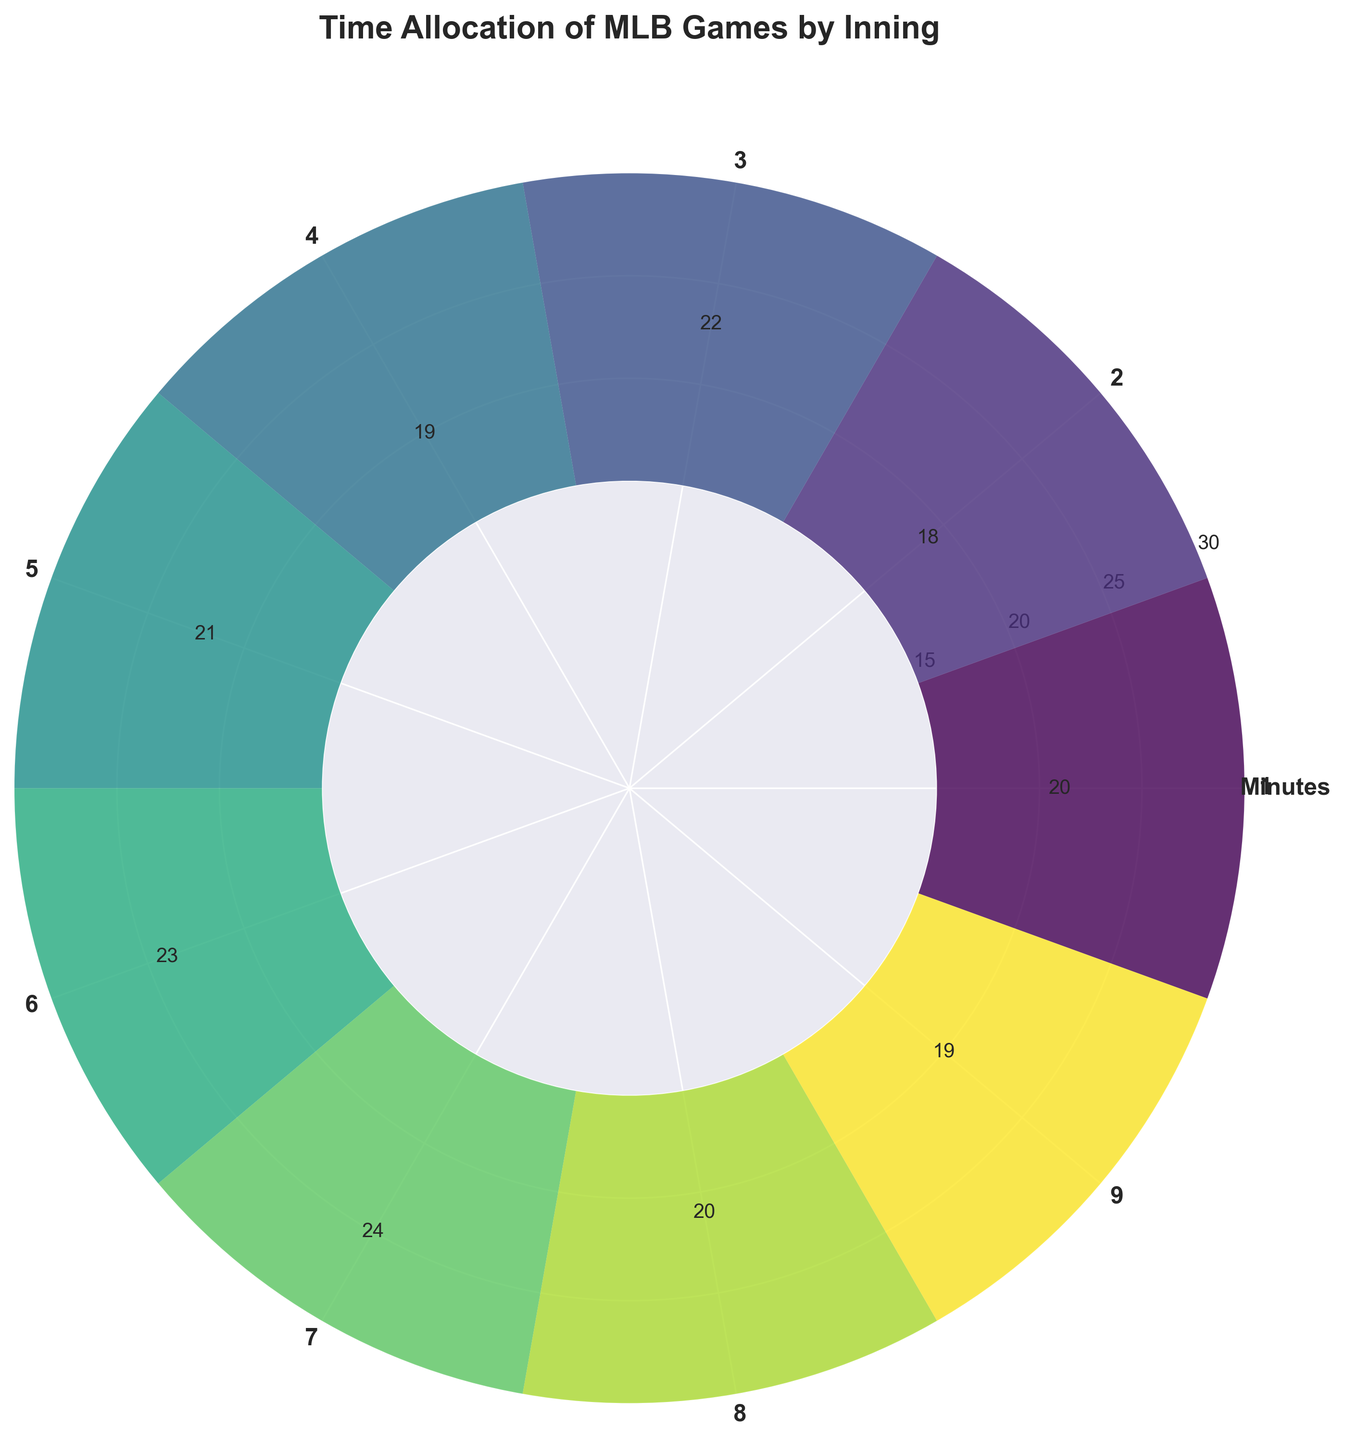Which inning has the highest time allocation? By examining the plot, the seventh inning has the highest bar, indicating it has the highest time allocation.
Answer: 7th inning What's the difference in time allocation between the third and fourth innings? The third inning has a time allocation of 22 minutes, and the fourth inning has 19 minutes. The difference is 22 - 19 = 3 minutes.
Answer: 3 minutes How many innings have a time allocation of 20 minutes or more? Checking the figure, the bars for the 1st, 3rd, 5th, 6th, 7th, and 8th innings reach or exceed 20 minutes. There are 6 such innings.
Answer: 6 innings What is the average time allocation per inning? Adding up the time allocations (20 + 18 + 22 + 19 + 21 + 23 + 24 + 20 + 19) gives 186 minutes. Dividing by the number of innings (9) results in an average of 186 / 9 = 20.67 minutes.
Answer: 20.67 minutes Which innings have the same time allocation? Looking at the plot, the 1st and 8th innings both show bars reaching 20 minutes, and the 4th and 9th innings both show bars reaching 19 minutes.
Answer: 1st and 8th, 4th and 9th What is the total time allocation for the ninth inning? The bar for the ninth inning is labeled with a time allocation of 19 minutes.
Answer: 19 minutes Which inning has the lowest time allocation? The lowest bar in the plot corresponds to the second inning, indicating it has the lowest time allocation of 18 minutes.
Answer: 2nd inning Are there any innings with a time allocation less than 19 minutes? The plot shows that the second inning has a bar representing a time allocation of 18 minutes.
Answer: Yes, the 2nd inning Which inning comes immediately after the inning with the highest time allocation? After the 7th inning, which has the highest time allocation of 24 minutes, comes the 8th inning.
Answer: 8th inning What is the sum of the time allocations for the 6th and 7th innings? The time allocations for the 6th and 7th innings are 23 and 24 minutes, respectively. Adding them gives 23 + 24 = 47 minutes.
Answer: 47 minutes 